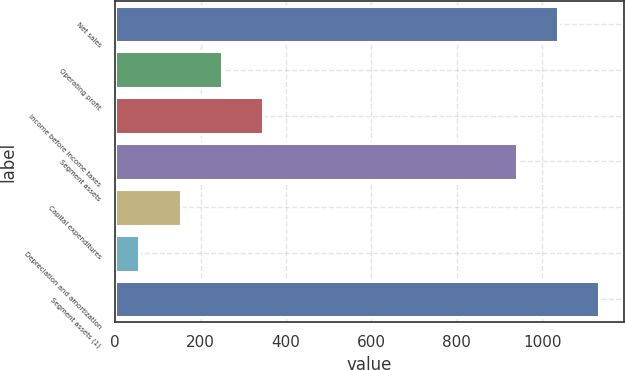Convert chart to OTSL. <chart><loc_0><loc_0><loc_500><loc_500><bar_chart><fcel>Net sales<fcel>Operating profit<fcel>Income before income taxes<fcel>Segment assets<fcel>Capital expenditures<fcel>Depreciation and amortization<fcel>Segment assets (1)<nl><fcel>1037.57<fcel>250.14<fcel>346.91<fcel>940.8<fcel>153.37<fcel>56.6<fcel>1134.34<nl></chart> 